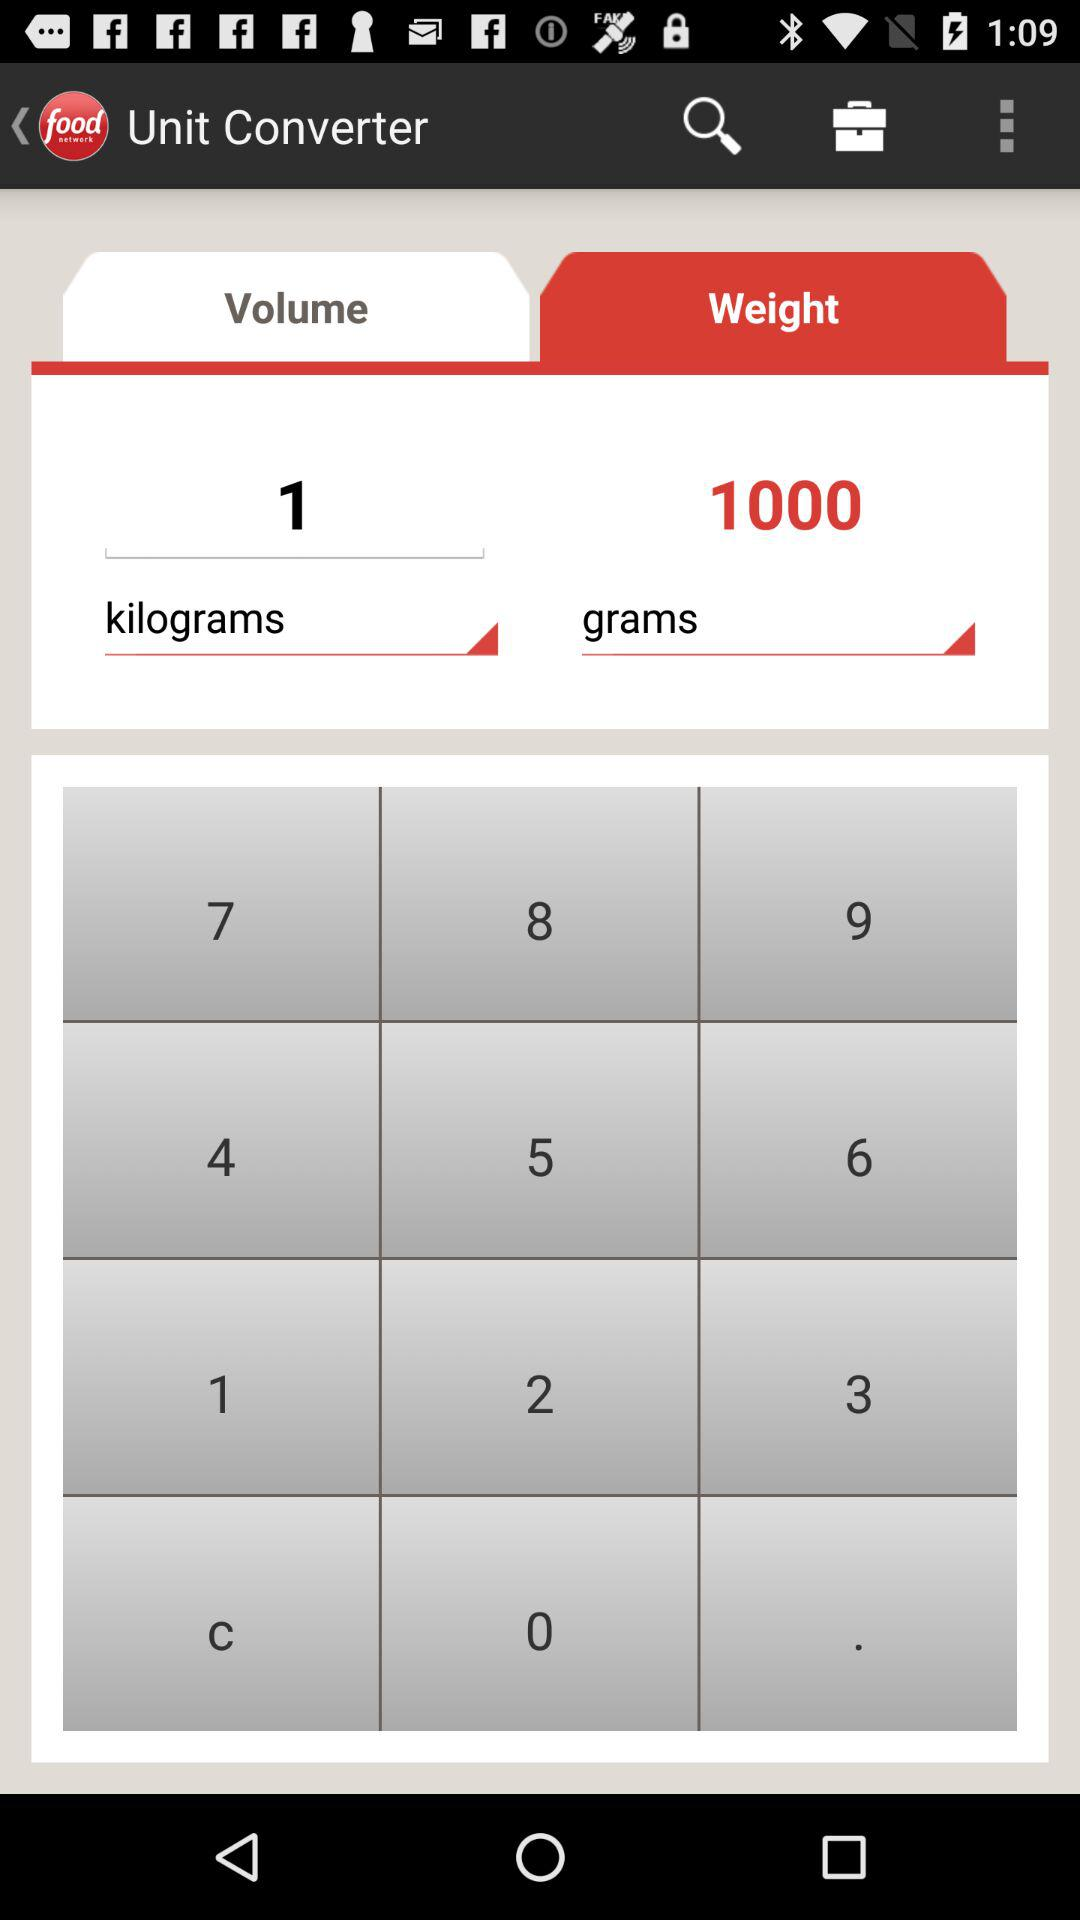What is the difference between the weight in kilograms and grams?
Answer the question using a single word or phrase. 1000 